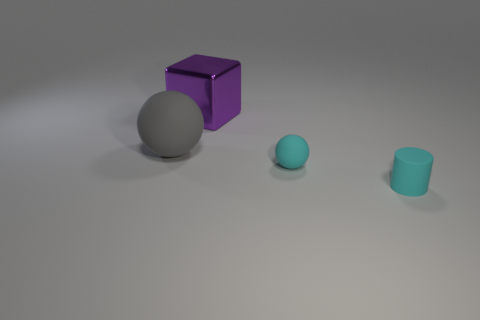There is a ball that is the same color as the matte cylinder; what material is it?
Your response must be concise. Rubber. What is the shape of the matte thing that is left of the cyan rubber sphere that is right of the purple cube?
Keep it short and to the point. Sphere. Are there any small cyan rubber things that have the same shape as the big purple metal object?
Ensure brevity in your answer.  No. Does the rubber cylinder have the same color as the small object that is behind the cyan cylinder?
Offer a terse response. Yes. There is a sphere that is the same color as the cylinder; what size is it?
Give a very brief answer. Small. Are there any cyan balls that have the same size as the rubber cylinder?
Ensure brevity in your answer.  Yes. Is the big gray object made of the same material as the cyan object that is behind the small cyan cylinder?
Your response must be concise. Yes. Is the number of brown cubes greater than the number of metallic cubes?
Offer a very short reply. No. How many cylinders are large purple shiny things or big gray things?
Provide a succinct answer. 0. The small ball is what color?
Offer a very short reply. Cyan. 